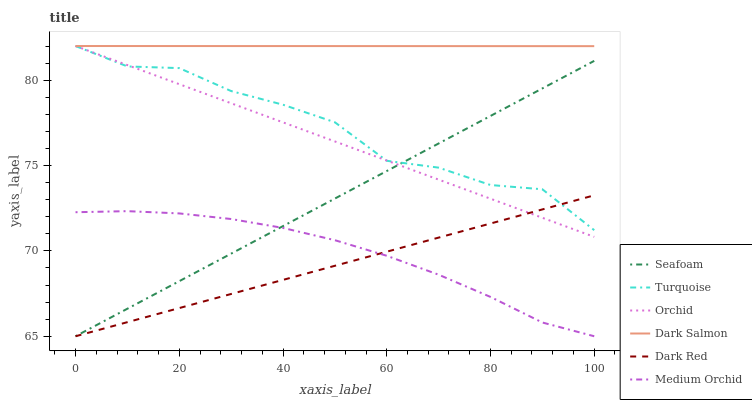Does Dark Red have the minimum area under the curve?
Answer yes or no. Yes. Does Dark Salmon have the maximum area under the curve?
Answer yes or no. Yes. Does Medium Orchid have the minimum area under the curve?
Answer yes or no. No. Does Medium Orchid have the maximum area under the curve?
Answer yes or no. No. Is Dark Red the smoothest?
Answer yes or no. Yes. Is Turquoise the roughest?
Answer yes or no. Yes. Is Medium Orchid the smoothest?
Answer yes or no. No. Is Medium Orchid the roughest?
Answer yes or no. No. Does Dark Red have the lowest value?
Answer yes or no. Yes. Does Dark Salmon have the lowest value?
Answer yes or no. No. Does Orchid have the highest value?
Answer yes or no. Yes. Does Dark Red have the highest value?
Answer yes or no. No. Is Dark Red less than Dark Salmon?
Answer yes or no. Yes. Is Turquoise greater than Medium Orchid?
Answer yes or no. Yes. Does Dark Salmon intersect Turquoise?
Answer yes or no. Yes. Is Dark Salmon less than Turquoise?
Answer yes or no. No. Is Dark Salmon greater than Turquoise?
Answer yes or no. No. Does Dark Red intersect Dark Salmon?
Answer yes or no. No. 